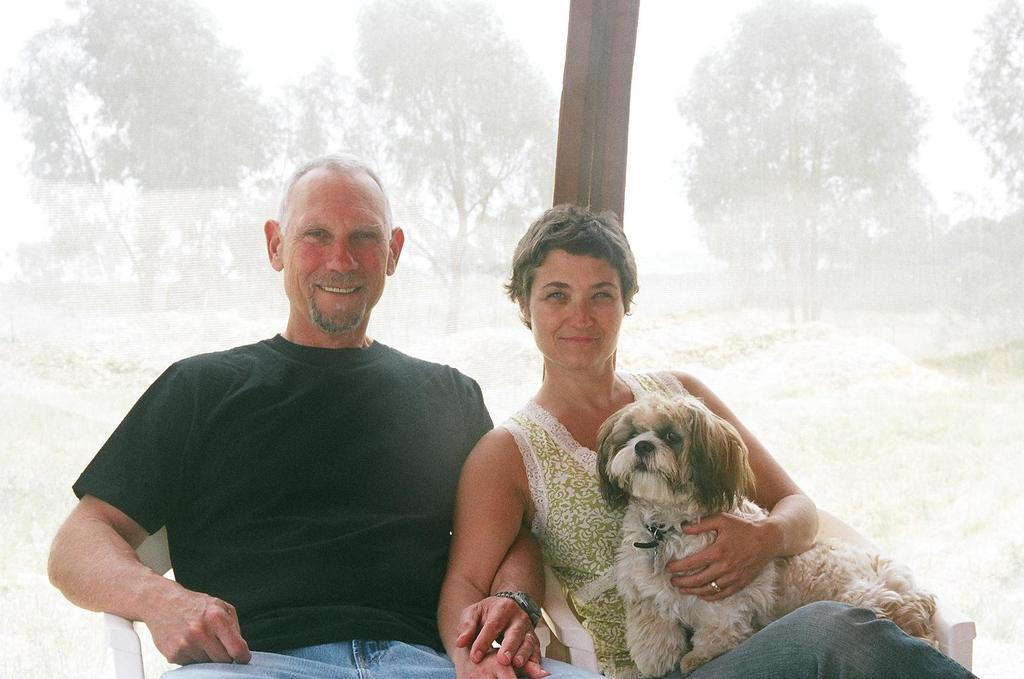How many people are in the image? There are two people in the image. Can you describe the individuals in the image? One of the people is a lady, and the other person is a guy. What is the guy doing in the image? The guy is sitting on a chair. What is the lady holding in the image? The lady is holding a dog. What type of cactus can be seen in the image? There is no cactus present in the image. Are the two people in the image engaged in a fight? No, the two people in the image are not engaged in a fight; they are simply sitting and holding a dog. 